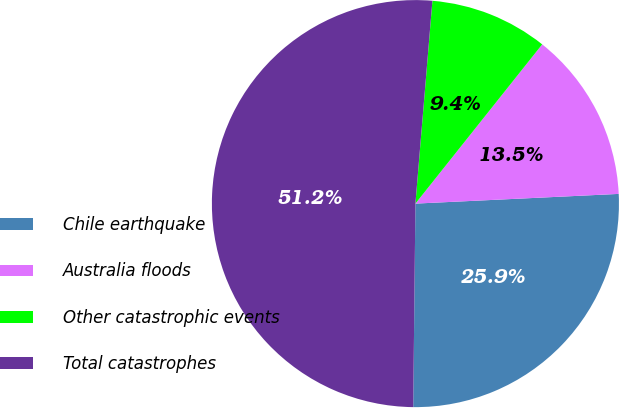<chart> <loc_0><loc_0><loc_500><loc_500><pie_chart><fcel>Chile earthquake<fcel>Australia floods<fcel>Other catastrophic events<fcel>Total catastrophes<nl><fcel>25.93%<fcel>13.54%<fcel>9.37%<fcel>51.16%<nl></chart> 